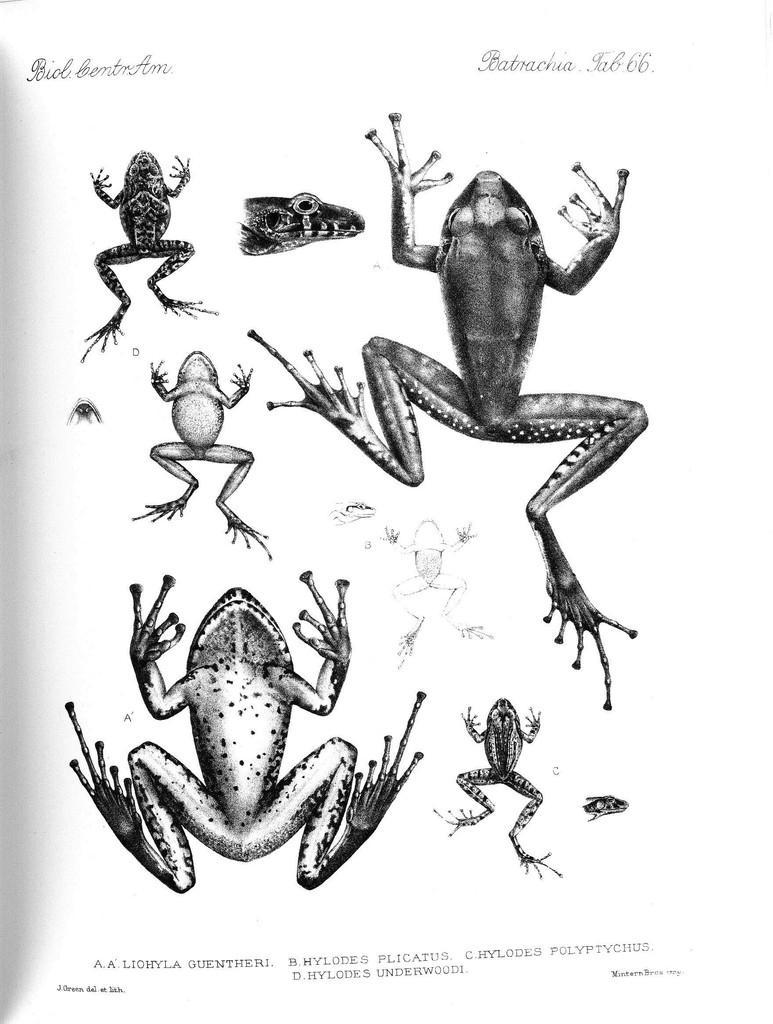Could you give a brief overview of what you see in this image? Here, we can see a picture, in that picture we can see some frogs. 